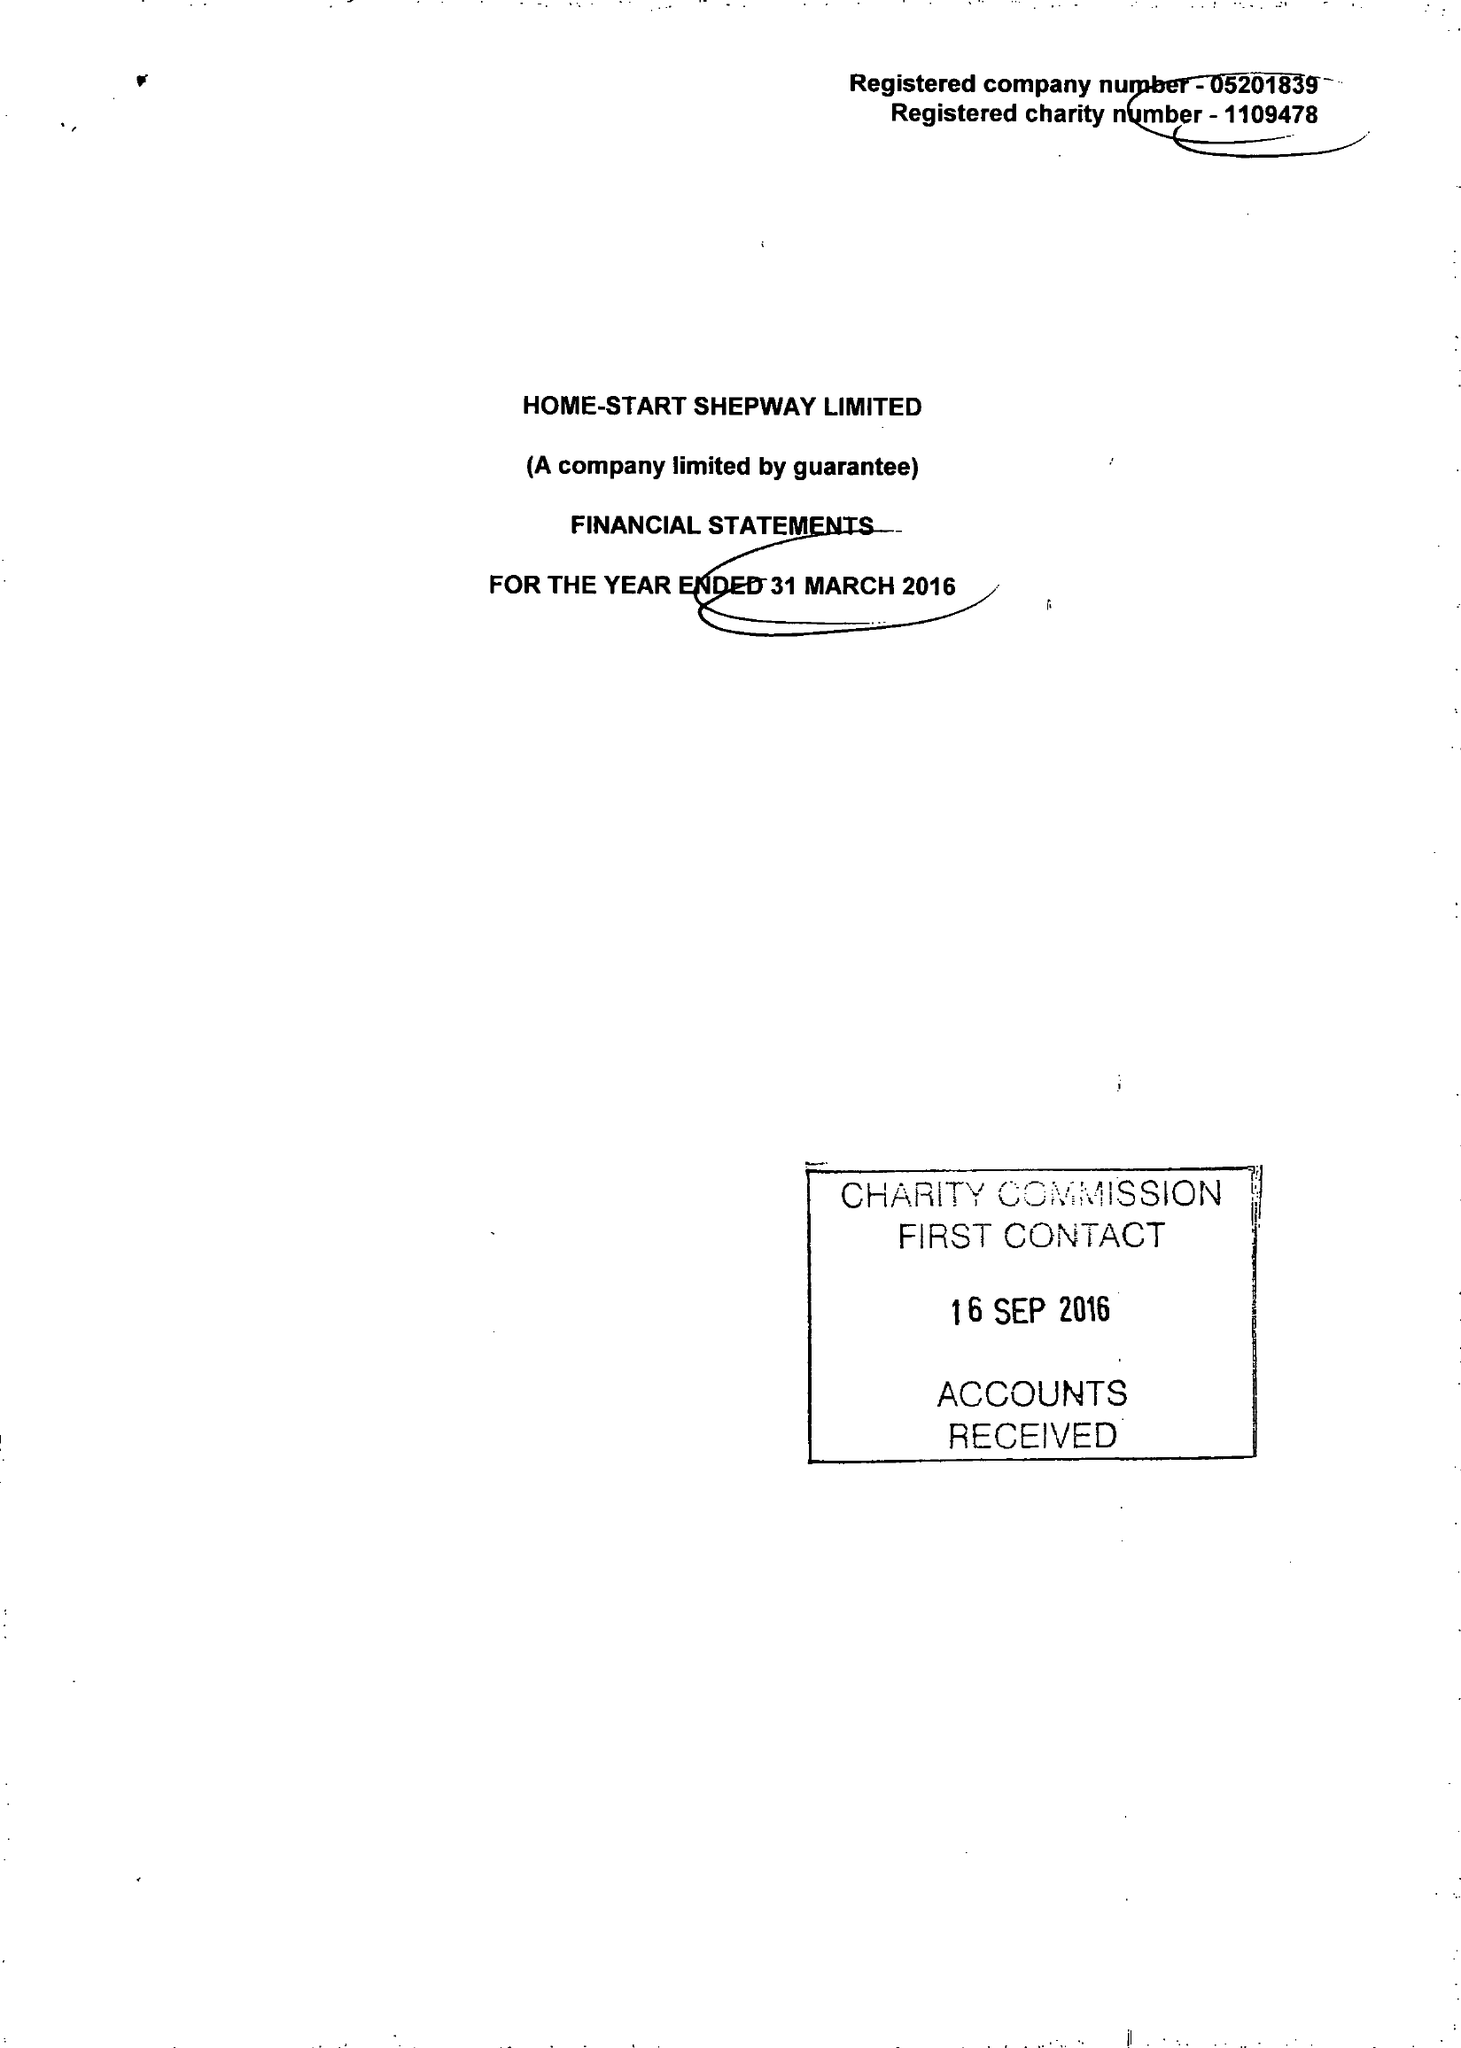What is the value for the address__postcode?
Answer the question using a single word or phrase. CT20 2AS 